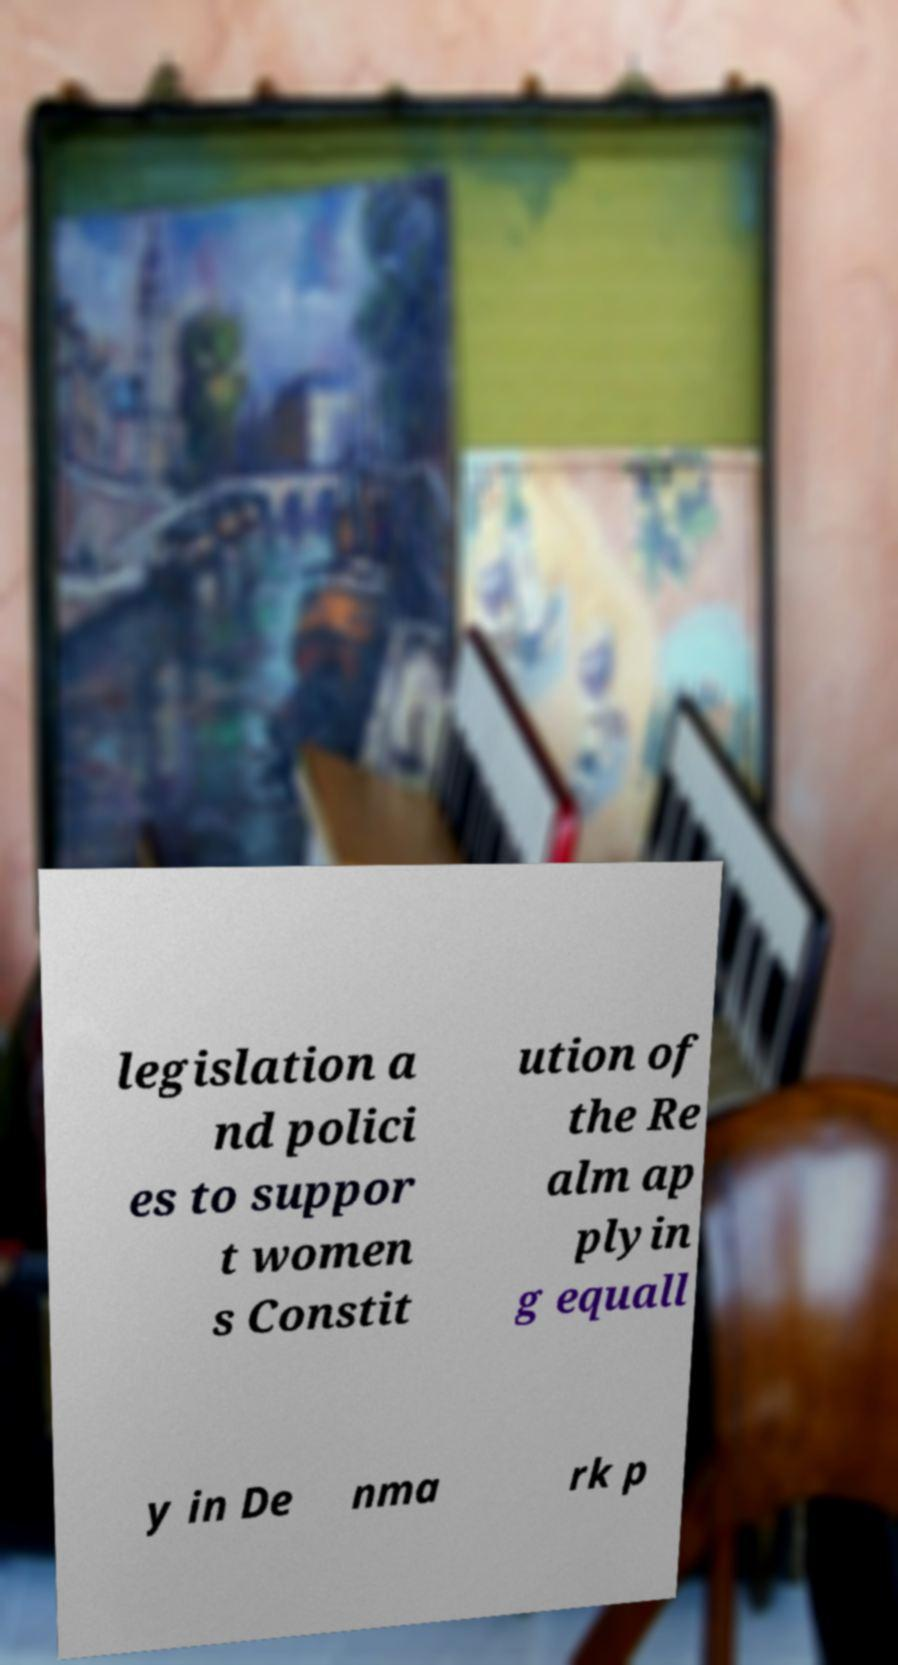Please identify and transcribe the text found in this image. legislation a nd polici es to suppor t women s Constit ution of the Re alm ap plyin g equall y in De nma rk p 